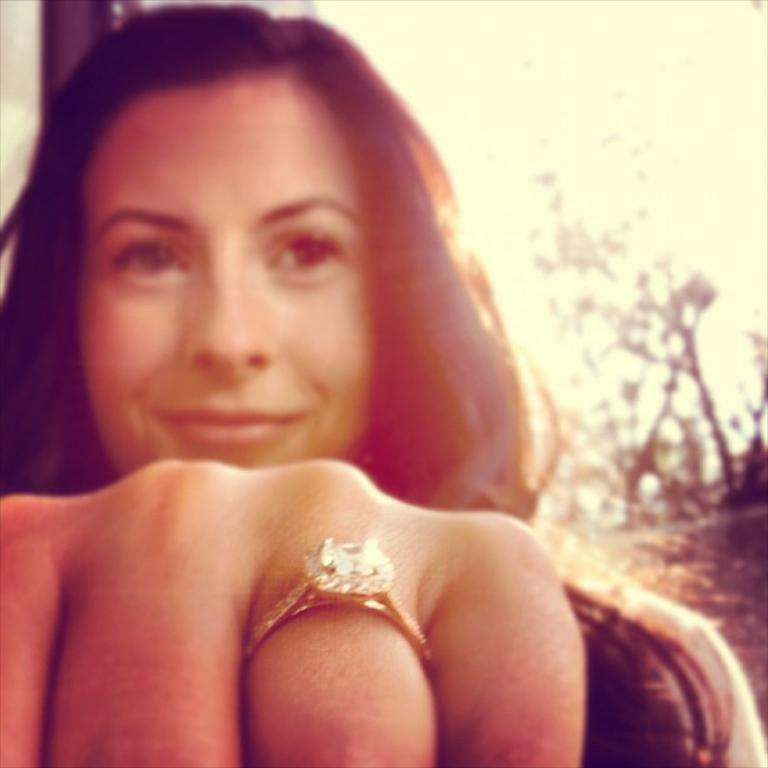Who is present in the image? There is a woman in the image. What can be seen on the left side of the image? There is a person's hand with a ring on the left side of the image. What is visible in the background of the image? There are trees visible in the background of the image. What type of behavior can be observed in the sticks in the image? There are no sticks present in the image, so it is not possible to observe any behavior in them. 